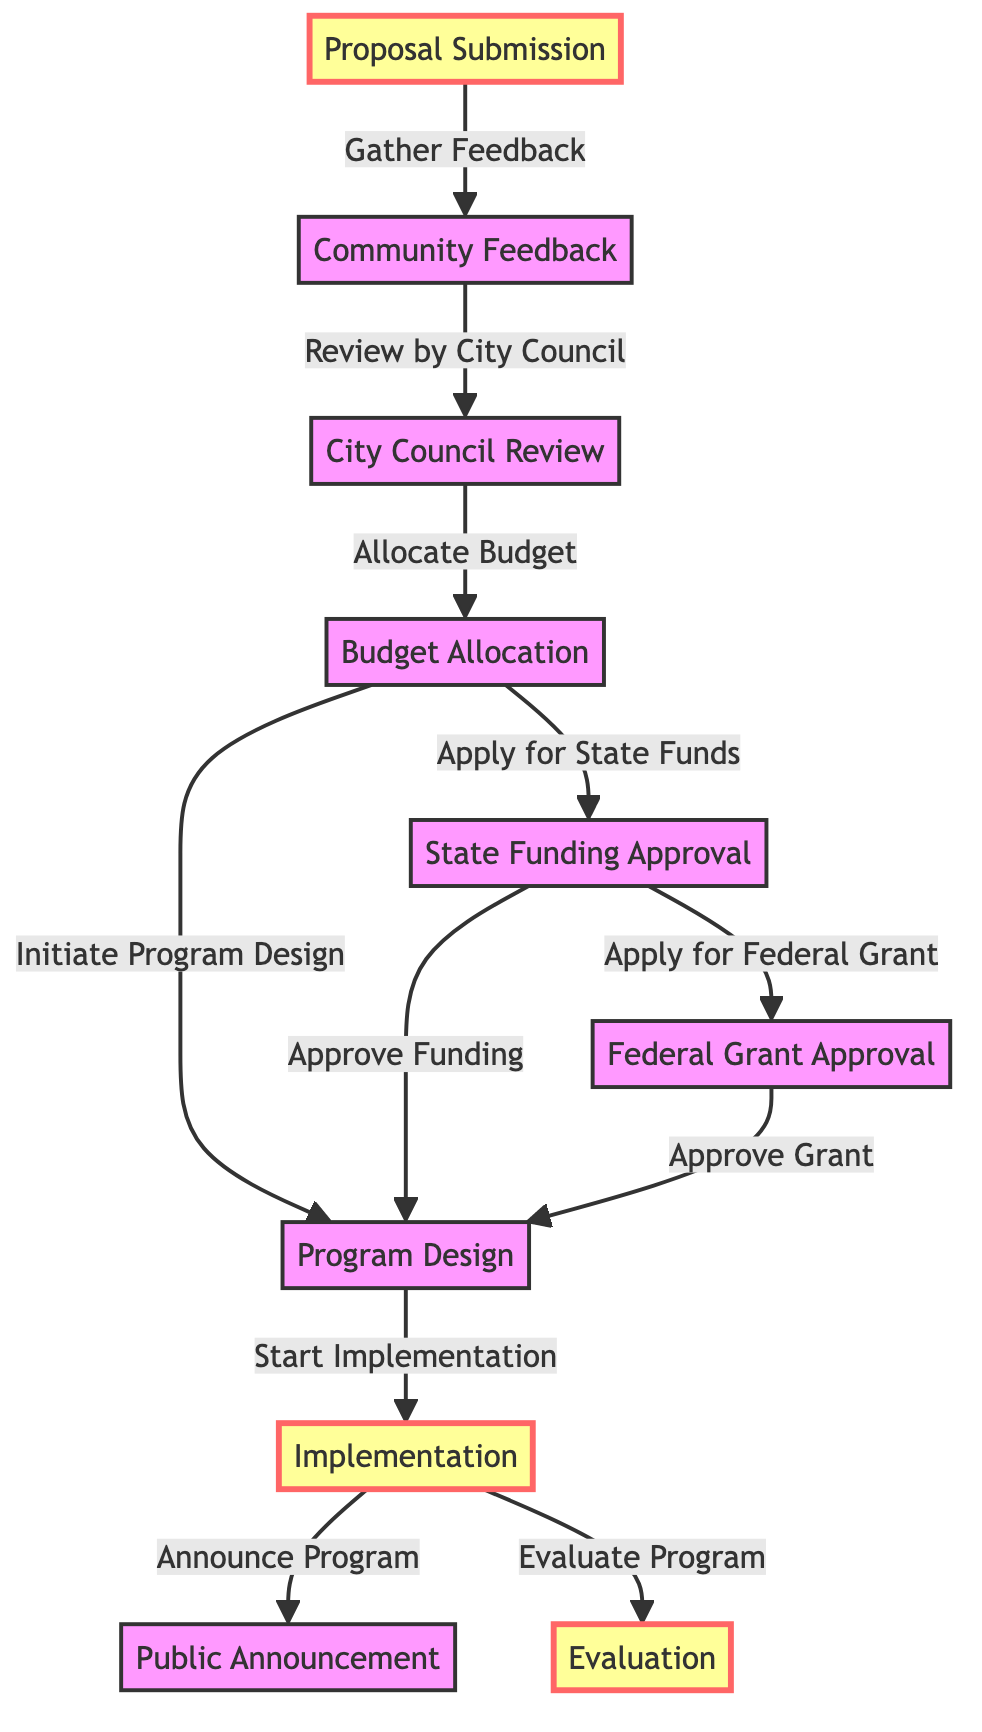What is the first step in the community service program life cycle? The first step in the life cycle is represented by the node labeled "Proposal Submission." This is the originating point of the process.
Answer: Proposal Submission How many nodes are in the diagram? The diagram contains ten nodes, each representing a distinct step or concept in the community service program life cycle.
Answer: 10 What is the relationship between "City Council Review" and "Budget Allocation"? The relationship is that the City Council Review leads to the Budget Allocation node; specifically, after the review, the council allocates the budget for the program.
Answer: Allocate Budget What comes after "Public Announcement"? After the Public Announcement, the process can be evaluated; this shows that evaluation follows the announcement in the flow of the program life cycle.
Answer: Evaluation Which two funding approvals are applied for after budget allocation? After budget allocation, the two funding approvals that are applied for are State Funding Approval and Federal Grant Approval, illustrating the steps needed for securing financial support.
Answer: State Funding Approval, Federal Grant Approval What is required before moving to program design? Before moving to Program Design, there is a need for Budget Allocation, which indicates that funding is a prerequisite for the design of the program.
Answer: Budget Allocation Which nodes are defined as important in the diagram? The important nodes identified in the diagram are "Proposal Submission," "Implementation," and "Evaluation," suggesting they are focal points in the process flow.
Answer: Proposal Submission, Implementation, Evaluation What happens after "State Funding Approval"? After State Funding Approval, the next step is to apply for Federal Grant Approval, which indicates a sequential process for acquiring necessary funding.
Answer: Apply for Federal Grant 